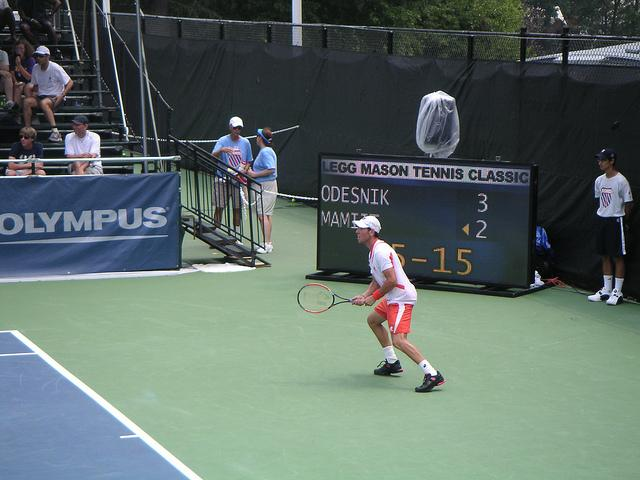What type of tennis game is being played here? Please explain your reasoning. singles. The names of the players are displayed on the board in the background. there are two types of tennis played, doubles and singles, and there is only one name displayed per line which is consistent for singles but if it were doubles both partners names would be displayed. 